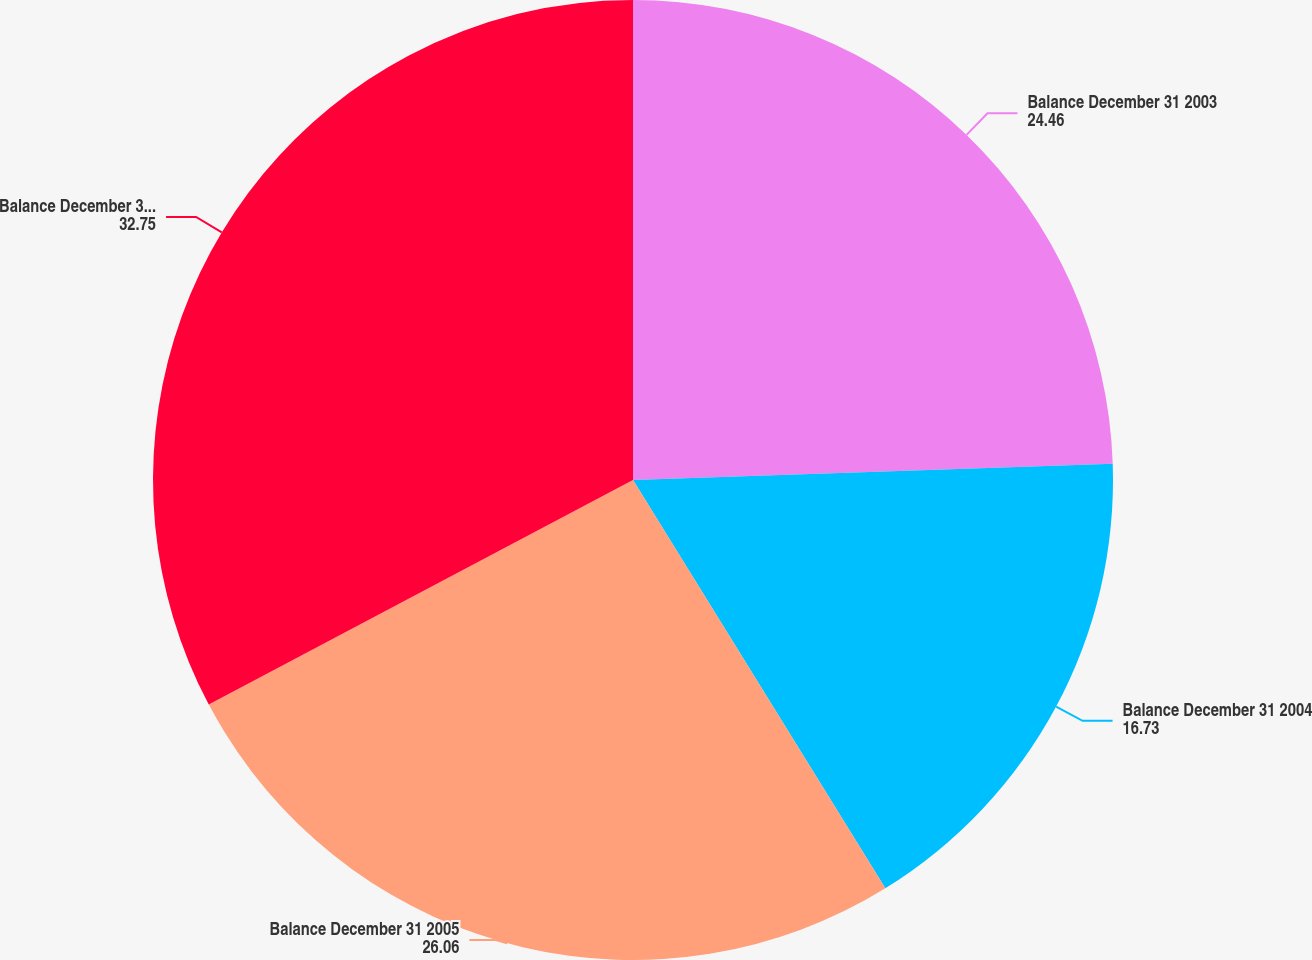Convert chart. <chart><loc_0><loc_0><loc_500><loc_500><pie_chart><fcel>Balance December 31 2003<fcel>Balance December 31 2004<fcel>Balance December 31 2005<fcel>Balance December 31 2006<nl><fcel>24.46%<fcel>16.73%<fcel>26.06%<fcel>32.75%<nl></chart> 